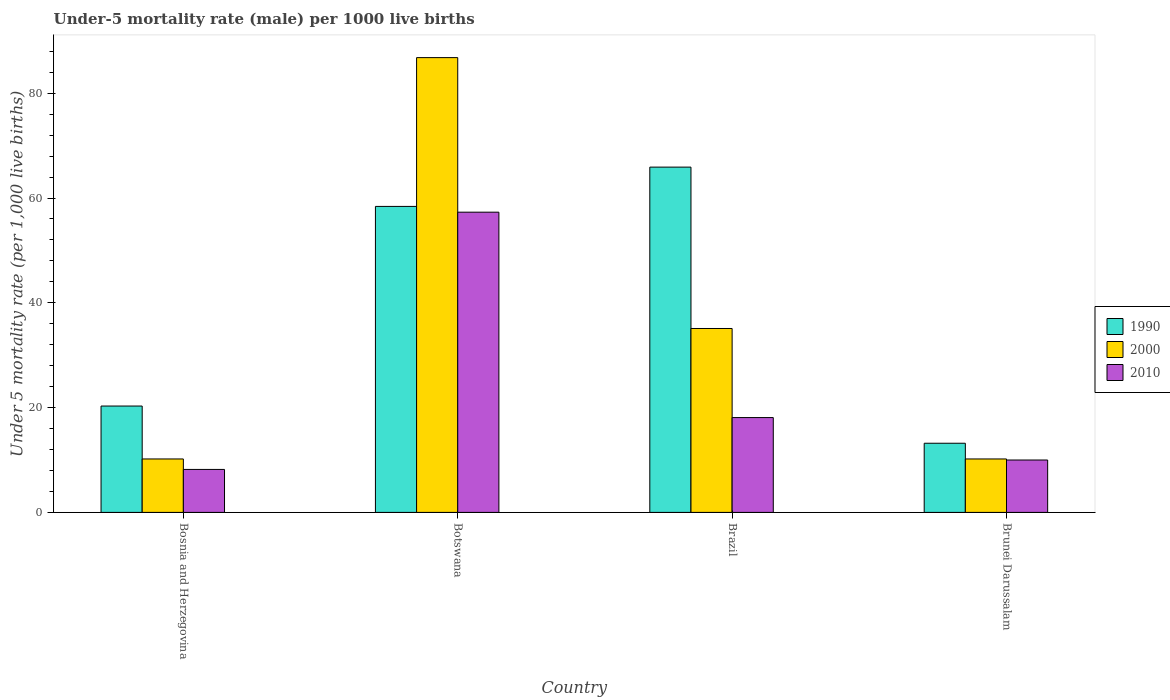Are the number of bars per tick equal to the number of legend labels?
Your answer should be very brief. Yes. What is the label of the 2nd group of bars from the left?
Offer a terse response. Botswana. In how many cases, is the number of bars for a given country not equal to the number of legend labels?
Provide a succinct answer. 0. What is the under-five mortality rate in 2010 in Brunei Darussalam?
Give a very brief answer. 10. Across all countries, what is the maximum under-five mortality rate in 2000?
Give a very brief answer. 86.8. Across all countries, what is the minimum under-five mortality rate in 2010?
Offer a very short reply. 8.2. In which country was the under-five mortality rate in 2000 maximum?
Your answer should be compact. Botswana. In which country was the under-five mortality rate in 1990 minimum?
Offer a very short reply. Brunei Darussalam. What is the total under-five mortality rate in 1990 in the graph?
Offer a very short reply. 157.8. What is the difference between the under-five mortality rate in 2010 in Botswana and that in Brunei Darussalam?
Offer a very short reply. 47.3. What is the difference between the under-five mortality rate in 2000 in Bosnia and Herzegovina and the under-five mortality rate in 2010 in Brazil?
Your response must be concise. -7.9. What is the average under-five mortality rate in 1990 per country?
Give a very brief answer. 39.45. What is the difference between the under-five mortality rate of/in 1990 and under-five mortality rate of/in 2000 in Botswana?
Offer a terse response. -28.4. In how many countries, is the under-five mortality rate in 1990 greater than 72?
Your answer should be very brief. 0. What is the ratio of the under-five mortality rate in 2010 in Bosnia and Herzegovina to that in Brazil?
Provide a succinct answer. 0.45. Is the under-five mortality rate in 2000 in Bosnia and Herzegovina less than that in Brunei Darussalam?
Ensure brevity in your answer.  No. What is the difference between the highest and the second highest under-five mortality rate in 2010?
Offer a terse response. 39.2. What is the difference between the highest and the lowest under-five mortality rate in 2000?
Give a very brief answer. 76.6. Is the sum of the under-five mortality rate in 2000 in Botswana and Brazil greater than the maximum under-five mortality rate in 2010 across all countries?
Your answer should be compact. Yes. Are all the bars in the graph horizontal?
Your answer should be compact. No. Are the values on the major ticks of Y-axis written in scientific E-notation?
Provide a succinct answer. No. Does the graph contain any zero values?
Provide a succinct answer. No. How are the legend labels stacked?
Provide a short and direct response. Vertical. What is the title of the graph?
Offer a terse response. Under-5 mortality rate (male) per 1000 live births. What is the label or title of the Y-axis?
Keep it short and to the point. Under 5 mortality rate (per 1,0 live births). What is the Under 5 mortality rate (per 1,000 live births) of 1990 in Bosnia and Herzegovina?
Offer a terse response. 20.3. What is the Under 5 mortality rate (per 1,000 live births) in 2010 in Bosnia and Herzegovina?
Ensure brevity in your answer.  8.2. What is the Under 5 mortality rate (per 1,000 live births) of 1990 in Botswana?
Give a very brief answer. 58.4. What is the Under 5 mortality rate (per 1,000 live births) in 2000 in Botswana?
Give a very brief answer. 86.8. What is the Under 5 mortality rate (per 1,000 live births) in 2010 in Botswana?
Your answer should be compact. 57.3. What is the Under 5 mortality rate (per 1,000 live births) of 1990 in Brazil?
Your response must be concise. 65.9. What is the Under 5 mortality rate (per 1,000 live births) in 2000 in Brazil?
Offer a very short reply. 35.1. What is the Under 5 mortality rate (per 1,000 live births) in 2010 in Brazil?
Keep it short and to the point. 18.1. What is the Under 5 mortality rate (per 1,000 live births) in 2010 in Brunei Darussalam?
Your answer should be compact. 10. Across all countries, what is the maximum Under 5 mortality rate (per 1,000 live births) of 1990?
Your answer should be very brief. 65.9. Across all countries, what is the maximum Under 5 mortality rate (per 1,000 live births) in 2000?
Provide a short and direct response. 86.8. Across all countries, what is the maximum Under 5 mortality rate (per 1,000 live births) of 2010?
Ensure brevity in your answer.  57.3. Across all countries, what is the minimum Under 5 mortality rate (per 1,000 live births) in 1990?
Your answer should be compact. 13.2. Across all countries, what is the minimum Under 5 mortality rate (per 1,000 live births) of 2000?
Keep it short and to the point. 10.2. Across all countries, what is the minimum Under 5 mortality rate (per 1,000 live births) of 2010?
Provide a succinct answer. 8.2. What is the total Under 5 mortality rate (per 1,000 live births) in 1990 in the graph?
Make the answer very short. 157.8. What is the total Under 5 mortality rate (per 1,000 live births) of 2000 in the graph?
Keep it short and to the point. 142.3. What is the total Under 5 mortality rate (per 1,000 live births) of 2010 in the graph?
Offer a terse response. 93.6. What is the difference between the Under 5 mortality rate (per 1,000 live births) of 1990 in Bosnia and Herzegovina and that in Botswana?
Your answer should be very brief. -38.1. What is the difference between the Under 5 mortality rate (per 1,000 live births) of 2000 in Bosnia and Herzegovina and that in Botswana?
Give a very brief answer. -76.6. What is the difference between the Under 5 mortality rate (per 1,000 live births) in 2010 in Bosnia and Herzegovina and that in Botswana?
Give a very brief answer. -49.1. What is the difference between the Under 5 mortality rate (per 1,000 live births) of 1990 in Bosnia and Herzegovina and that in Brazil?
Make the answer very short. -45.6. What is the difference between the Under 5 mortality rate (per 1,000 live births) of 2000 in Bosnia and Herzegovina and that in Brazil?
Make the answer very short. -24.9. What is the difference between the Under 5 mortality rate (per 1,000 live births) of 2010 in Bosnia and Herzegovina and that in Brazil?
Make the answer very short. -9.9. What is the difference between the Under 5 mortality rate (per 1,000 live births) in 1990 in Bosnia and Herzegovina and that in Brunei Darussalam?
Offer a very short reply. 7.1. What is the difference between the Under 5 mortality rate (per 1,000 live births) in 2000 in Bosnia and Herzegovina and that in Brunei Darussalam?
Keep it short and to the point. 0. What is the difference between the Under 5 mortality rate (per 1,000 live births) of 2010 in Bosnia and Herzegovina and that in Brunei Darussalam?
Keep it short and to the point. -1.8. What is the difference between the Under 5 mortality rate (per 1,000 live births) of 2000 in Botswana and that in Brazil?
Your answer should be very brief. 51.7. What is the difference between the Under 5 mortality rate (per 1,000 live births) in 2010 in Botswana and that in Brazil?
Keep it short and to the point. 39.2. What is the difference between the Under 5 mortality rate (per 1,000 live births) in 1990 in Botswana and that in Brunei Darussalam?
Keep it short and to the point. 45.2. What is the difference between the Under 5 mortality rate (per 1,000 live births) in 2000 in Botswana and that in Brunei Darussalam?
Your answer should be compact. 76.6. What is the difference between the Under 5 mortality rate (per 1,000 live births) in 2010 in Botswana and that in Brunei Darussalam?
Your response must be concise. 47.3. What is the difference between the Under 5 mortality rate (per 1,000 live births) in 1990 in Brazil and that in Brunei Darussalam?
Offer a very short reply. 52.7. What is the difference between the Under 5 mortality rate (per 1,000 live births) of 2000 in Brazil and that in Brunei Darussalam?
Your answer should be compact. 24.9. What is the difference between the Under 5 mortality rate (per 1,000 live births) in 1990 in Bosnia and Herzegovina and the Under 5 mortality rate (per 1,000 live births) in 2000 in Botswana?
Your answer should be compact. -66.5. What is the difference between the Under 5 mortality rate (per 1,000 live births) in 1990 in Bosnia and Herzegovina and the Under 5 mortality rate (per 1,000 live births) in 2010 in Botswana?
Provide a short and direct response. -37. What is the difference between the Under 5 mortality rate (per 1,000 live births) in 2000 in Bosnia and Herzegovina and the Under 5 mortality rate (per 1,000 live births) in 2010 in Botswana?
Your answer should be very brief. -47.1. What is the difference between the Under 5 mortality rate (per 1,000 live births) of 1990 in Bosnia and Herzegovina and the Under 5 mortality rate (per 1,000 live births) of 2000 in Brazil?
Offer a terse response. -14.8. What is the difference between the Under 5 mortality rate (per 1,000 live births) of 1990 in Bosnia and Herzegovina and the Under 5 mortality rate (per 1,000 live births) of 2000 in Brunei Darussalam?
Provide a succinct answer. 10.1. What is the difference between the Under 5 mortality rate (per 1,000 live births) of 1990 in Bosnia and Herzegovina and the Under 5 mortality rate (per 1,000 live births) of 2010 in Brunei Darussalam?
Your answer should be very brief. 10.3. What is the difference between the Under 5 mortality rate (per 1,000 live births) in 2000 in Bosnia and Herzegovina and the Under 5 mortality rate (per 1,000 live births) in 2010 in Brunei Darussalam?
Provide a short and direct response. 0.2. What is the difference between the Under 5 mortality rate (per 1,000 live births) of 1990 in Botswana and the Under 5 mortality rate (per 1,000 live births) of 2000 in Brazil?
Make the answer very short. 23.3. What is the difference between the Under 5 mortality rate (per 1,000 live births) in 1990 in Botswana and the Under 5 mortality rate (per 1,000 live births) in 2010 in Brazil?
Your response must be concise. 40.3. What is the difference between the Under 5 mortality rate (per 1,000 live births) in 2000 in Botswana and the Under 5 mortality rate (per 1,000 live births) in 2010 in Brazil?
Your response must be concise. 68.7. What is the difference between the Under 5 mortality rate (per 1,000 live births) in 1990 in Botswana and the Under 5 mortality rate (per 1,000 live births) in 2000 in Brunei Darussalam?
Offer a terse response. 48.2. What is the difference between the Under 5 mortality rate (per 1,000 live births) of 1990 in Botswana and the Under 5 mortality rate (per 1,000 live births) of 2010 in Brunei Darussalam?
Offer a very short reply. 48.4. What is the difference between the Under 5 mortality rate (per 1,000 live births) of 2000 in Botswana and the Under 5 mortality rate (per 1,000 live births) of 2010 in Brunei Darussalam?
Ensure brevity in your answer.  76.8. What is the difference between the Under 5 mortality rate (per 1,000 live births) of 1990 in Brazil and the Under 5 mortality rate (per 1,000 live births) of 2000 in Brunei Darussalam?
Your answer should be compact. 55.7. What is the difference between the Under 5 mortality rate (per 1,000 live births) in 1990 in Brazil and the Under 5 mortality rate (per 1,000 live births) in 2010 in Brunei Darussalam?
Your response must be concise. 55.9. What is the difference between the Under 5 mortality rate (per 1,000 live births) in 2000 in Brazil and the Under 5 mortality rate (per 1,000 live births) in 2010 in Brunei Darussalam?
Your response must be concise. 25.1. What is the average Under 5 mortality rate (per 1,000 live births) in 1990 per country?
Your response must be concise. 39.45. What is the average Under 5 mortality rate (per 1,000 live births) of 2000 per country?
Give a very brief answer. 35.58. What is the average Under 5 mortality rate (per 1,000 live births) of 2010 per country?
Your answer should be compact. 23.4. What is the difference between the Under 5 mortality rate (per 1,000 live births) in 1990 and Under 5 mortality rate (per 1,000 live births) in 2000 in Bosnia and Herzegovina?
Offer a very short reply. 10.1. What is the difference between the Under 5 mortality rate (per 1,000 live births) in 1990 and Under 5 mortality rate (per 1,000 live births) in 2010 in Bosnia and Herzegovina?
Make the answer very short. 12.1. What is the difference between the Under 5 mortality rate (per 1,000 live births) in 2000 and Under 5 mortality rate (per 1,000 live births) in 2010 in Bosnia and Herzegovina?
Offer a terse response. 2. What is the difference between the Under 5 mortality rate (per 1,000 live births) in 1990 and Under 5 mortality rate (per 1,000 live births) in 2000 in Botswana?
Offer a very short reply. -28.4. What is the difference between the Under 5 mortality rate (per 1,000 live births) of 2000 and Under 5 mortality rate (per 1,000 live births) of 2010 in Botswana?
Offer a terse response. 29.5. What is the difference between the Under 5 mortality rate (per 1,000 live births) in 1990 and Under 5 mortality rate (per 1,000 live births) in 2000 in Brazil?
Your answer should be compact. 30.8. What is the difference between the Under 5 mortality rate (per 1,000 live births) of 1990 and Under 5 mortality rate (per 1,000 live births) of 2010 in Brazil?
Ensure brevity in your answer.  47.8. What is the difference between the Under 5 mortality rate (per 1,000 live births) in 2000 and Under 5 mortality rate (per 1,000 live births) in 2010 in Brazil?
Offer a terse response. 17. What is the difference between the Under 5 mortality rate (per 1,000 live births) of 1990 and Under 5 mortality rate (per 1,000 live births) of 2010 in Brunei Darussalam?
Give a very brief answer. 3.2. What is the difference between the Under 5 mortality rate (per 1,000 live births) of 2000 and Under 5 mortality rate (per 1,000 live births) of 2010 in Brunei Darussalam?
Your response must be concise. 0.2. What is the ratio of the Under 5 mortality rate (per 1,000 live births) in 1990 in Bosnia and Herzegovina to that in Botswana?
Ensure brevity in your answer.  0.35. What is the ratio of the Under 5 mortality rate (per 1,000 live births) in 2000 in Bosnia and Herzegovina to that in Botswana?
Your answer should be compact. 0.12. What is the ratio of the Under 5 mortality rate (per 1,000 live births) in 2010 in Bosnia and Herzegovina to that in Botswana?
Offer a terse response. 0.14. What is the ratio of the Under 5 mortality rate (per 1,000 live births) in 1990 in Bosnia and Herzegovina to that in Brazil?
Make the answer very short. 0.31. What is the ratio of the Under 5 mortality rate (per 1,000 live births) of 2000 in Bosnia and Herzegovina to that in Brazil?
Offer a terse response. 0.29. What is the ratio of the Under 5 mortality rate (per 1,000 live births) of 2010 in Bosnia and Herzegovina to that in Brazil?
Ensure brevity in your answer.  0.45. What is the ratio of the Under 5 mortality rate (per 1,000 live births) of 1990 in Bosnia and Herzegovina to that in Brunei Darussalam?
Offer a very short reply. 1.54. What is the ratio of the Under 5 mortality rate (per 1,000 live births) of 2000 in Bosnia and Herzegovina to that in Brunei Darussalam?
Give a very brief answer. 1. What is the ratio of the Under 5 mortality rate (per 1,000 live births) of 2010 in Bosnia and Herzegovina to that in Brunei Darussalam?
Provide a succinct answer. 0.82. What is the ratio of the Under 5 mortality rate (per 1,000 live births) of 1990 in Botswana to that in Brazil?
Keep it short and to the point. 0.89. What is the ratio of the Under 5 mortality rate (per 1,000 live births) in 2000 in Botswana to that in Brazil?
Your answer should be compact. 2.47. What is the ratio of the Under 5 mortality rate (per 1,000 live births) in 2010 in Botswana to that in Brazil?
Provide a short and direct response. 3.17. What is the ratio of the Under 5 mortality rate (per 1,000 live births) in 1990 in Botswana to that in Brunei Darussalam?
Your response must be concise. 4.42. What is the ratio of the Under 5 mortality rate (per 1,000 live births) in 2000 in Botswana to that in Brunei Darussalam?
Make the answer very short. 8.51. What is the ratio of the Under 5 mortality rate (per 1,000 live births) of 2010 in Botswana to that in Brunei Darussalam?
Ensure brevity in your answer.  5.73. What is the ratio of the Under 5 mortality rate (per 1,000 live births) in 1990 in Brazil to that in Brunei Darussalam?
Give a very brief answer. 4.99. What is the ratio of the Under 5 mortality rate (per 1,000 live births) in 2000 in Brazil to that in Brunei Darussalam?
Offer a very short reply. 3.44. What is the ratio of the Under 5 mortality rate (per 1,000 live births) of 2010 in Brazil to that in Brunei Darussalam?
Your response must be concise. 1.81. What is the difference between the highest and the second highest Under 5 mortality rate (per 1,000 live births) of 2000?
Make the answer very short. 51.7. What is the difference between the highest and the second highest Under 5 mortality rate (per 1,000 live births) of 2010?
Offer a terse response. 39.2. What is the difference between the highest and the lowest Under 5 mortality rate (per 1,000 live births) in 1990?
Offer a very short reply. 52.7. What is the difference between the highest and the lowest Under 5 mortality rate (per 1,000 live births) in 2000?
Make the answer very short. 76.6. What is the difference between the highest and the lowest Under 5 mortality rate (per 1,000 live births) of 2010?
Make the answer very short. 49.1. 